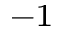Convert formula to latex. <formula><loc_0><loc_0><loc_500><loc_500>^ { - 1 }</formula> 